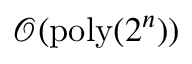Convert formula to latex. <formula><loc_0><loc_0><loc_500><loc_500>\mathcal { O } ( p o l y ( 2 ^ { n } ) )</formula> 